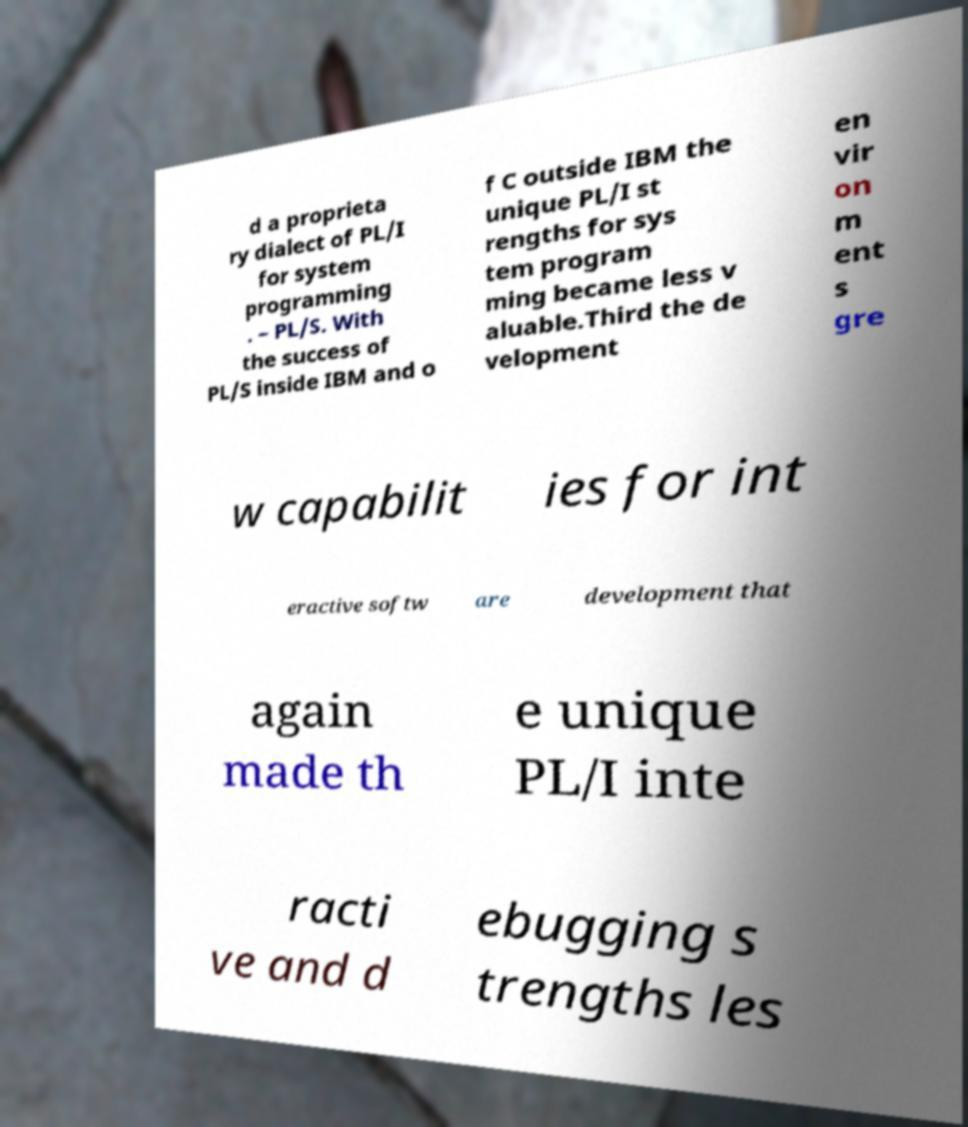There's text embedded in this image that I need extracted. Can you transcribe it verbatim? d a proprieta ry dialect of PL/I for system programming . – PL/S. With the success of PL/S inside IBM and o f C outside IBM the unique PL/I st rengths for sys tem program ming became less v aluable.Third the de velopment en vir on m ent s gre w capabilit ies for int eractive softw are development that again made th e unique PL/I inte racti ve and d ebugging s trengths les 